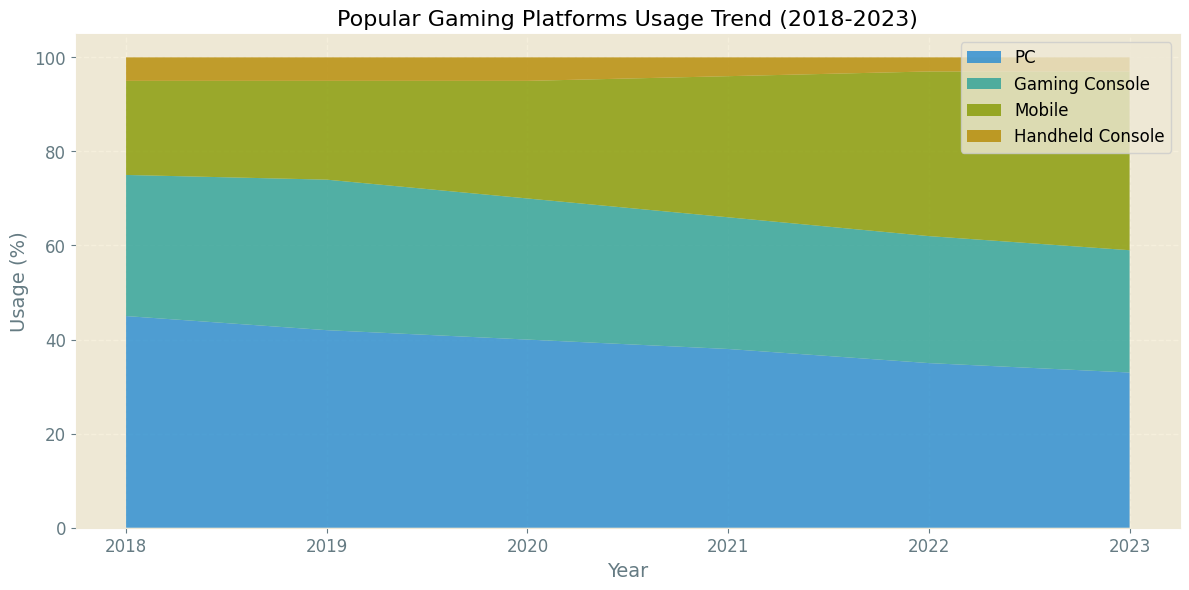Which platform saw the most consistent increase in usage over the years? The mobile platform saw consistent growth every year from 20% in 2018 to 38% in 2023. This can be observed as the corresponding area in the chart keeps increasing each year.
Answer: Mobile Which year had the highest overall usage of handheld consoles? Handheld console usage slightly dropped from 5% in 2018 to 3% in 2023. Therefore, the year 2018 had the highest usage of handheld consoles at 5%.
Answer: 2018 Compare PC and Mobile usage in 2020. Which one was used more? In 2020, the PC usage was 40%, and mobile usage was 25%. The height of the shaded area for PC is significantly taller than the one for mobile, showing PC was used more in 2020.
Answer: PC What was the difference in PC usage between 2018 and 2023? In 2018, PC usage was 45%. By 2023, it dropped to 33%. The difference is calculated as 45% - 33% = 12%.
Answer: 12% Which platform has shown a decreasing trend over the past five years? PC's usage decreased from 45% in 2018 to 33% in 2023, indicating a decreasing trend. This is observed from the reduced height of the shaded area corresponding to PC.
Answer: PC Which platform had the highest usage in 2023? In 2023, mobile had the highest usage among all platforms at 38%. This is observed from the tallest shaded area in the chart for that year.
Answer: Mobile How did the usage of gaming consoles change from 2019 to 2021? In 2019, the gaming console usage was 32%. By 2021, it decreased to 28%. The observed decrease is 32% - 28% = 4%.
Answer: Decreased by 4% Sum of mobile and handheld console usage in 2022? In 2022, mobile usage was 35% and handheld console usage was 3%. Adding these together gives 35% + 3% = 38%.
Answer: 38% Compare the usage trend of PC and gaming consoles from 2018 to 2023. Which declined more? PC usage dropped from 45% to 33%, a decrease of 12%. Gaming consoles went from 30% to 26%, a decrease of 4%. Therefore, PC usage declined more.
Answer: PC Between 2021 and 2022, which platform showed the most significant increase in usage? Mobile usage increased from 30% in 2021 to 35% in 2022, an increase of 5%. This is the most significant increase for any platform during that period.
Answer: Mobile 